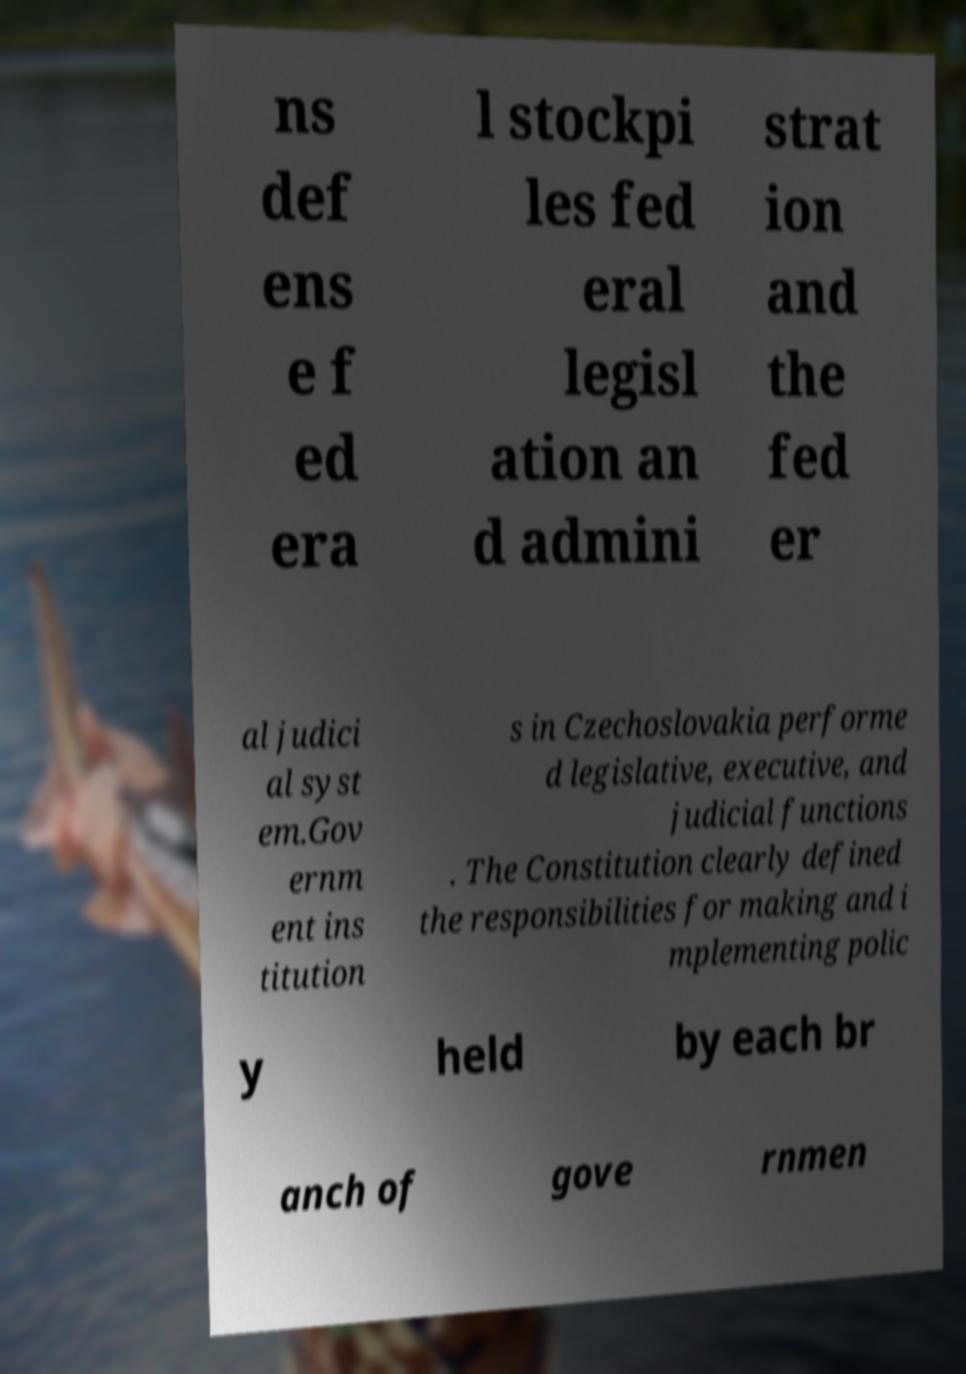Can you read and provide the text displayed in the image?This photo seems to have some interesting text. Can you extract and type it out for me? ns def ens e f ed era l stockpi les fed eral legisl ation an d admini strat ion and the fed er al judici al syst em.Gov ernm ent ins titution s in Czechoslovakia performe d legislative, executive, and judicial functions . The Constitution clearly defined the responsibilities for making and i mplementing polic y held by each br anch of gove rnmen 